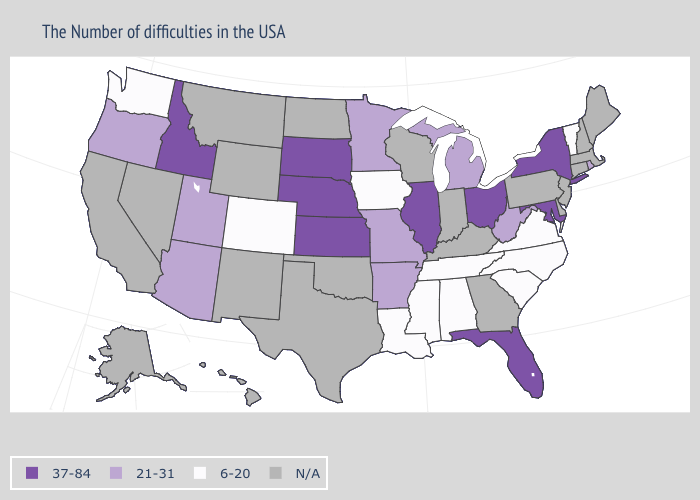What is the value of Hawaii?
Answer briefly. N/A. Name the states that have a value in the range N/A?
Quick response, please. Maine, Massachusetts, New Hampshire, Connecticut, New Jersey, Delaware, Pennsylvania, Georgia, Kentucky, Indiana, Wisconsin, Oklahoma, Texas, North Dakota, Wyoming, New Mexico, Montana, Nevada, California, Alaska, Hawaii. Name the states that have a value in the range 21-31?
Concise answer only. Rhode Island, West Virginia, Michigan, Missouri, Arkansas, Minnesota, Utah, Arizona, Oregon. Among the states that border Vermont , which have the lowest value?
Write a very short answer. New York. What is the value of New Jersey?
Answer briefly. N/A. What is the highest value in states that border Wyoming?
Quick response, please. 37-84. What is the value of South Carolina?
Write a very short answer. 6-20. Does Washington have the lowest value in the West?
Answer briefly. Yes. Name the states that have a value in the range 21-31?
Short answer required. Rhode Island, West Virginia, Michigan, Missouri, Arkansas, Minnesota, Utah, Arizona, Oregon. What is the value of California?
Answer briefly. N/A. Among the states that border Connecticut , which have the lowest value?
Short answer required. Rhode Island. Name the states that have a value in the range 6-20?
Be succinct. Vermont, Virginia, North Carolina, South Carolina, Alabama, Tennessee, Mississippi, Louisiana, Iowa, Colorado, Washington. Name the states that have a value in the range 37-84?
Write a very short answer. New York, Maryland, Ohio, Florida, Illinois, Kansas, Nebraska, South Dakota, Idaho. What is the highest value in the MidWest ?
Write a very short answer. 37-84. 